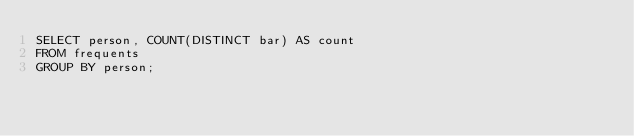<code> <loc_0><loc_0><loc_500><loc_500><_SQL_>SELECT person, COUNT(DISTINCT bar) AS count
FROM frequents
GROUP BY person;</code> 